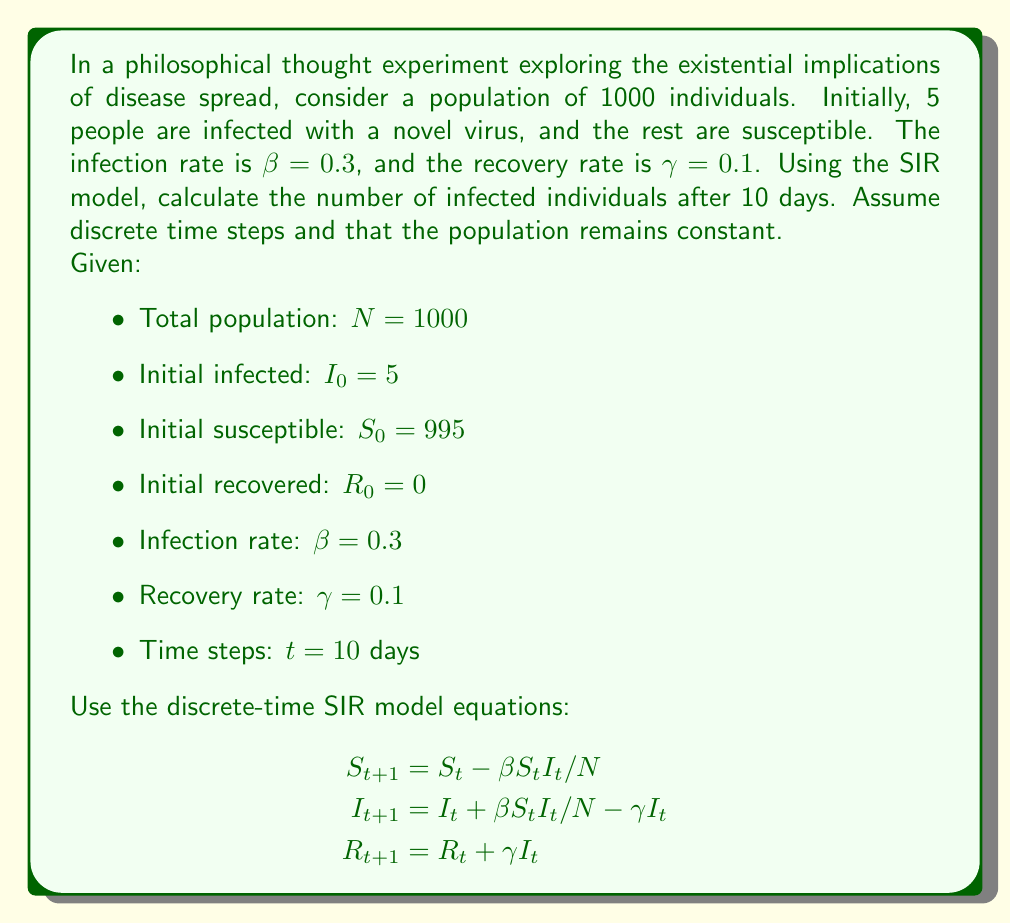What is the answer to this math problem? To solve this problem, we'll use the discrete-time SIR model equations to calculate the number of susceptible, infected, and recovered individuals for each day, up to day 10.

Let's start by setting up a table to track the values:

Day (t) | S | I | R
0 | 995 | 5 | 0

Now, we'll calculate the values for each subsequent day:

Day 1:
$S_1 = 995 - 0.3 \cdot 995 \cdot 5 / 1000 = 993.5125$
$I_1 = 5 + 0.3 \cdot 995 \cdot 5 / 1000 - 0.1 \cdot 5 = 6.4875$
$R_1 = 0 + 0.1 \cdot 5 = 0.5$

Day 2:
$S_2 = 993.5125 - 0.3 \cdot 993.5125 \cdot 6.4875 / 1000 = 991.5743$
$I_2 = 6.4875 + 0.3 \cdot 993.5125 \cdot 6.4875 / 1000 - 0.1 \cdot 6.4875 = 8.3507$
$R_2 = 0.5 + 0.1 \cdot 6.4875 = 1.1488$

We continue this process for the remaining days. Here's a summary of the results:

Day (t) | S | I | R
0 | 995.0000 | 5.0000 | 0.0000
1 | 993.5125 | 6.4875 | 0.5000
2 | 991.5743 | 8.3507 | 1.1488
3 | 989.0834 | 10.6645 | 2.0259
4 | 985.9343 | 13.5259 | 3.1136
5 | 982.0145 | 17.0057 | 3.5536
6 | 977.1998 | 21.1993 | 5.2747
7 | 971.3448 | 26.1683 | 7.0607
8 | 964.3000 | 32.0178 | 9.2560
9 | 955.8993 | 38.7926 | 10.8819
10 | 945.9581 | 46.5873 | 13.0284

After 10 days, the number of infected individuals is approximately 46.5873.
Answer: The number of infected individuals after 10 days is approximately 47 (rounded to the nearest whole number). 